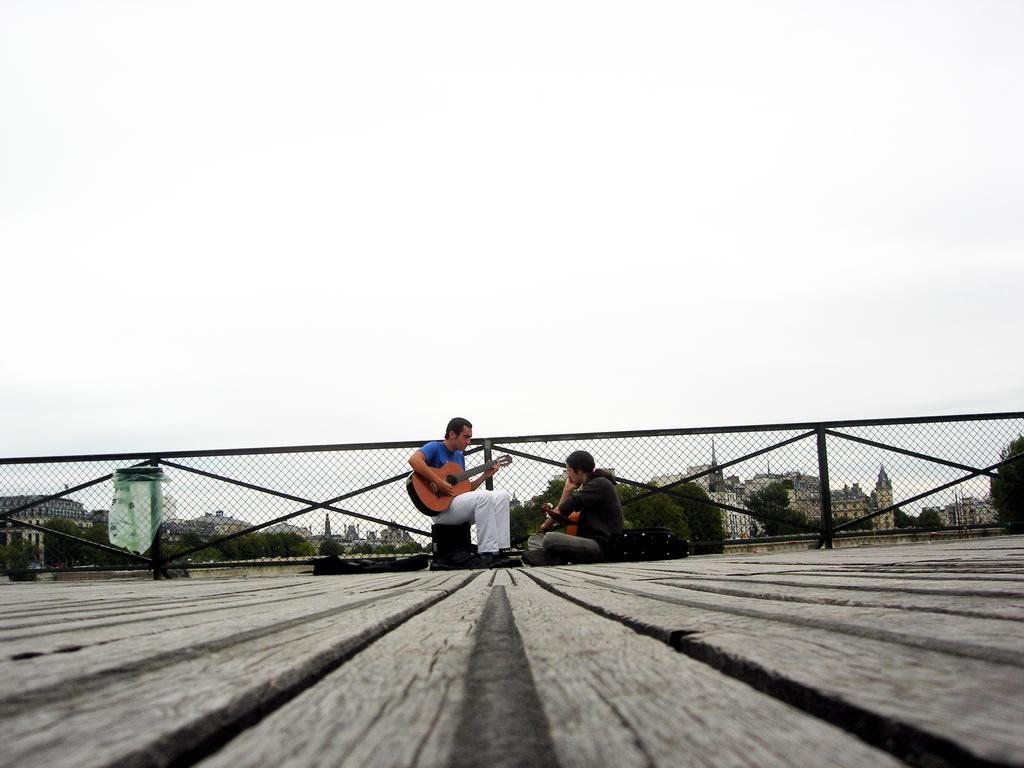What is the man in the image doing? The man is sitting and holding a guitar. Who else is present in the image? There is a woman in the image. How is the woman positioned in relation to the man? The woman is sitting in front of the man. What can be seen in the background of the image? There is a railing and the sky visible in the background of the image. What type of scarf is the boot wearing in the image? There is no scarf or boot present in the image. What question is the man asking the woman in the image? The image does not depict a conversation or any questions being asked. 